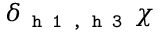<formula> <loc_0><loc_0><loc_500><loc_500>\delta _ { h 1 , h 3 } \chi</formula> 